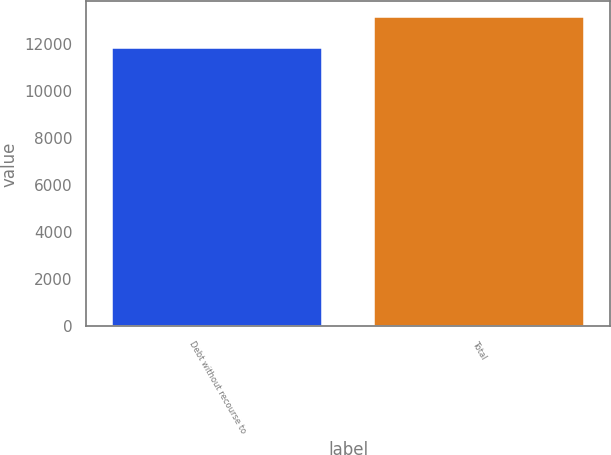Convert chart to OTSL. <chart><loc_0><loc_0><loc_500><loc_500><bar_chart><fcel>Debt without recourse to<fcel>Total<nl><fcel>11853<fcel>13173<nl></chart> 